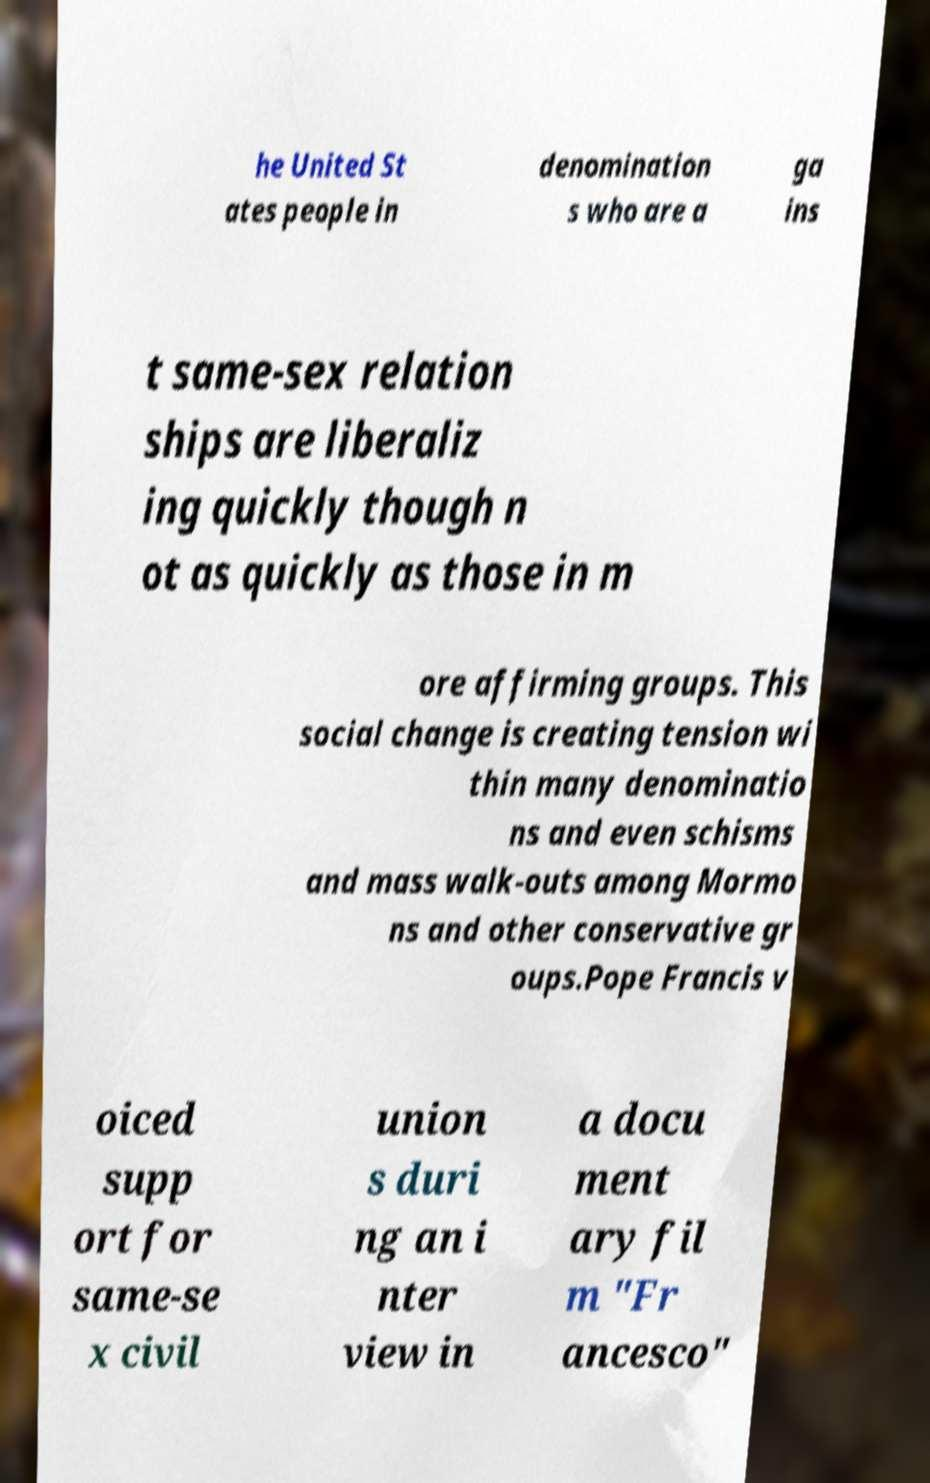I need the written content from this picture converted into text. Can you do that? he United St ates people in denomination s who are a ga ins t same-sex relation ships are liberaliz ing quickly though n ot as quickly as those in m ore affirming groups. This social change is creating tension wi thin many denominatio ns and even schisms and mass walk-outs among Mormo ns and other conservative gr oups.Pope Francis v oiced supp ort for same-se x civil union s duri ng an i nter view in a docu ment ary fil m "Fr ancesco" 